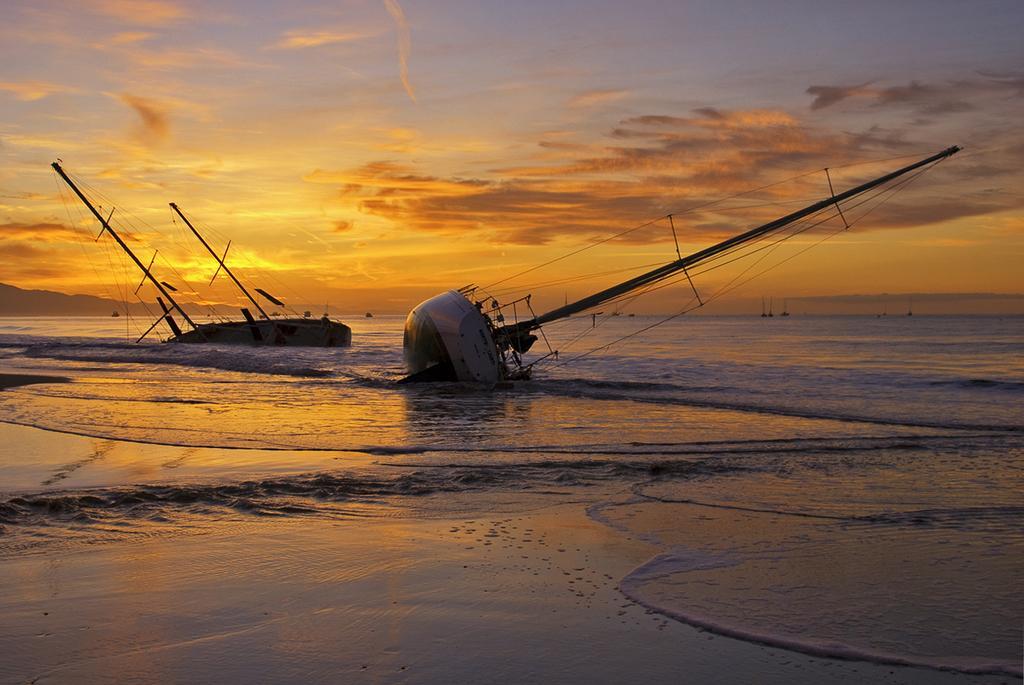Could you give a brief overview of what you see in this image? In this image we can see some boats on the ocean, two of them are tilted, also we can see the cloudy sky. 